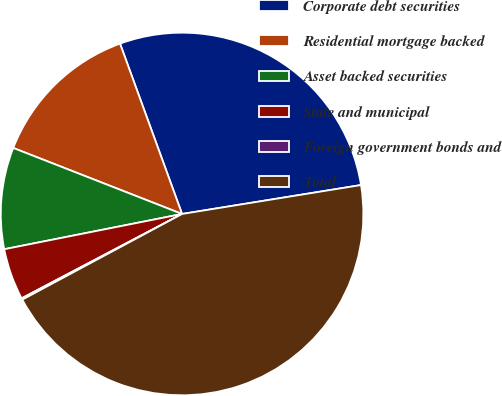<chart> <loc_0><loc_0><loc_500><loc_500><pie_chart><fcel>Corporate debt securities<fcel>Residential mortgage backed<fcel>Asset backed securities<fcel>State and municipal<fcel>Foreign government bonds and<fcel>Total<nl><fcel>28.01%<fcel>13.51%<fcel>9.05%<fcel>4.59%<fcel>0.13%<fcel>44.72%<nl></chart> 